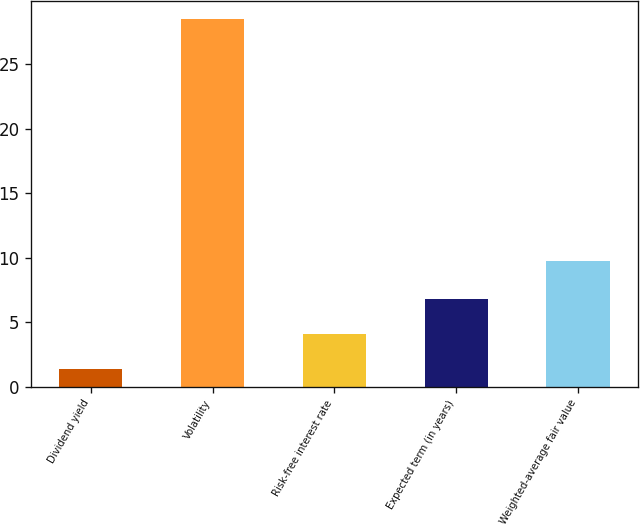Convert chart to OTSL. <chart><loc_0><loc_0><loc_500><loc_500><bar_chart><fcel>Dividend yield<fcel>Volatility<fcel>Risk-free interest rate<fcel>Expected term (in years)<fcel>Weighted-average fair value<nl><fcel>1.34<fcel>28.49<fcel>4.05<fcel>6.76<fcel>9.71<nl></chart> 